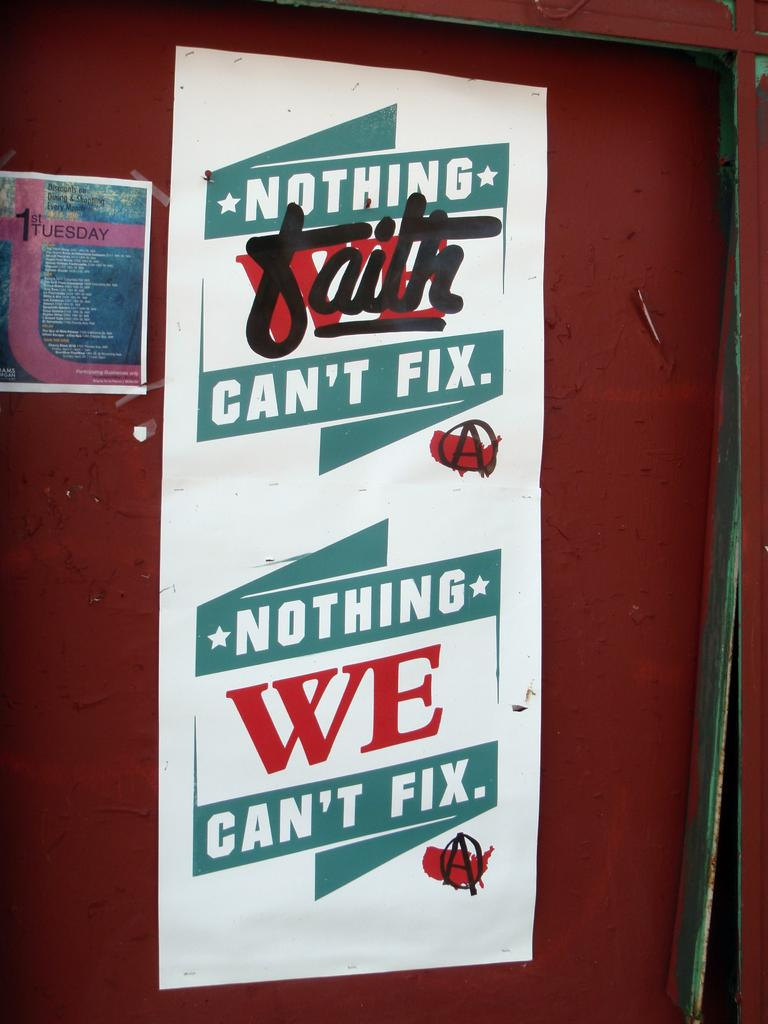<image>
Present a compact description of the photo's key features. A poster on a red door reads Nothing Faith Can't Fix, Nothing We Can't Fix. 